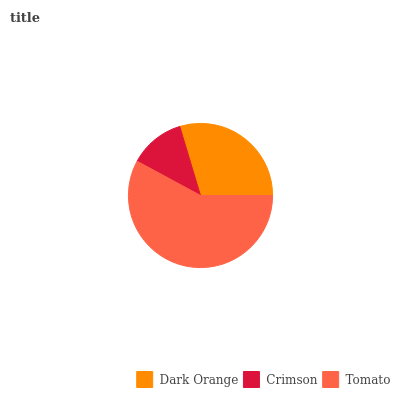Is Crimson the minimum?
Answer yes or no. Yes. Is Tomato the maximum?
Answer yes or no. Yes. Is Tomato the minimum?
Answer yes or no. No. Is Crimson the maximum?
Answer yes or no. No. Is Tomato greater than Crimson?
Answer yes or no. Yes. Is Crimson less than Tomato?
Answer yes or no. Yes. Is Crimson greater than Tomato?
Answer yes or no. No. Is Tomato less than Crimson?
Answer yes or no. No. Is Dark Orange the high median?
Answer yes or no. Yes. Is Dark Orange the low median?
Answer yes or no. Yes. Is Crimson the high median?
Answer yes or no. No. Is Tomato the low median?
Answer yes or no. No. 